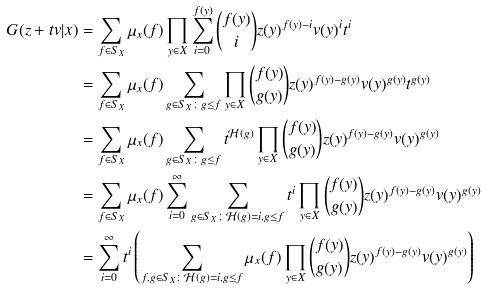Convert formula to latex. <formula><loc_0><loc_0><loc_500><loc_500>G ( z + t v | x ) & = \sum _ { f \in S _ { X } } \mu _ { x } ( f ) \prod _ { y \in X } \sum _ { i = 0 } ^ { f ( y ) } \binom { f ( y ) } { i } z ( y ) ^ { f ( y ) - i } v ( y ) ^ { i } t ^ { i } \\ & = \sum _ { f \in S _ { X } } \mu _ { x } ( f ) \sum _ { g \in S _ { X } \colon g \leq f } \prod _ { y \in X } \binom { f ( y ) } { g ( y ) } z ( y ) ^ { f ( y ) - g ( y ) } v ( y ) ^ { g ( y ) } t ^ { g ( y ) } \\ & = \sum _ { f \in S _ { X } } \mu _ { x } ( f ) \sum _ { g \in S _ { X } \colon g \leq f } t ^ { \mathcal { H } ( g ) } \prod _ { y \in X } \binom { f ( y ) } { g ( y ) } z ( y ) ^ { f ( y ) - g ( y ) } v ( y ) ^ { g ( y ) } \\ & = \sum _ { f \in S _ { X } } \mu _ { x } ( f ) \sum _ { i = 0 } ^ { \infty } \sum _ { g \in S _ { X } \colon \mathcal { H } ( g ) = i , g \leq f } t ^ { i } \prod _ { y \in X } \binom { f ( y ) } { g ( y ) } z ( y ) ^ { f ( y ) - g ( y ) } v ( y ) ^ { g ( y ) } \\ & = \sum _ { i = 0 } ^ { \infty } t ^ { i } \left ( \sum _ { f , g \in S _ { X } \colon \mathcal { H } ( g ) = i , g \leq f } \mu _ { x } ( f ) \prod _ { y \in X } \binom { f ( y ) } { g ( y ) } z ( y ) ^ { f ( y ) - g ( y ) } v ( y ) ^ { g ( y ) } \right ) \\</formula> 